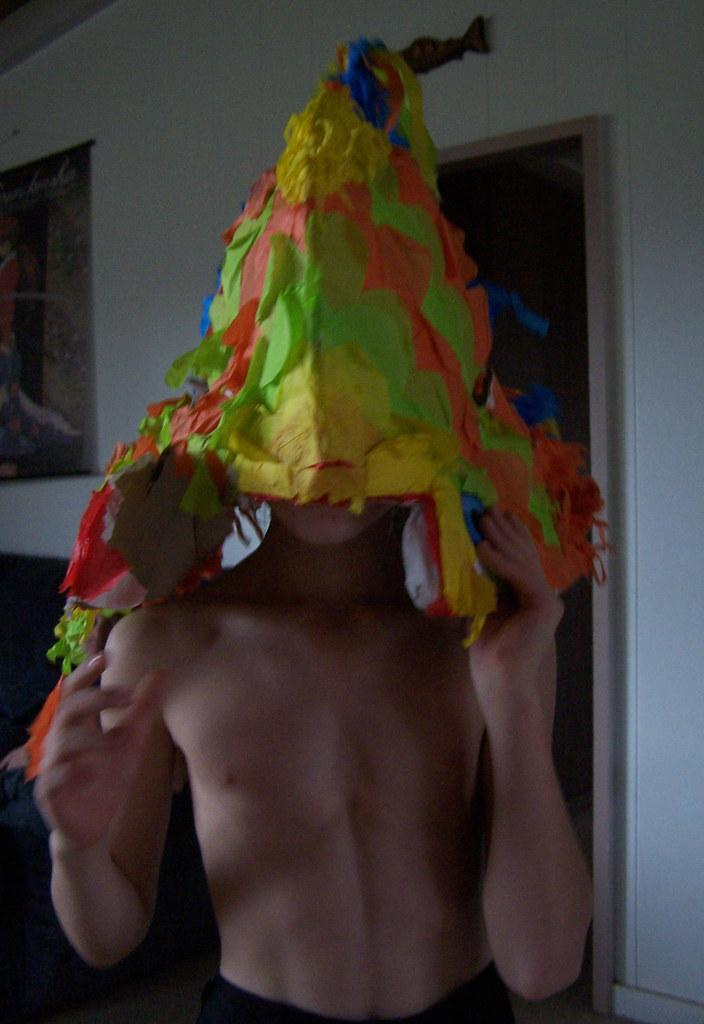Who or what is present in the image? There is a person in the image. What is the person wearing on their head? The person is wearing a hat. What can be seen in the background of the image? There is a wall in the background of the image. What type of oven is visible in the image? There is no oven present in the image. Can you describe the person's wings in the image? The person does not have wings in the image. 